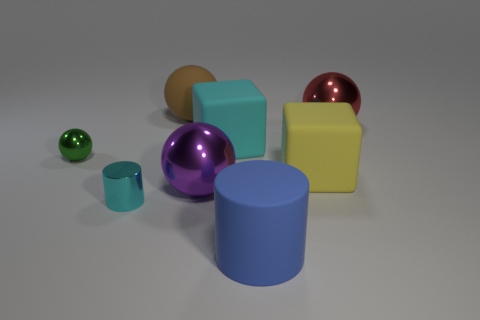There is a metallic thing on the right side of the big block left of the big matte thing in front of the cyan metal thing; what shape is it?
Make the answer very short. Sphere. What number of other things are the same color as the tiny cylinder?
Provide a short and direct response. 1. Is the number of large cyan objects in front of the large blue thing greater than the number of cyan shiny cylinders on the right side of the big red shiny sphere?
Provide a succinct answer. No. There is a yellow block; are there any big cylinders behind it?
Your answer should be very brief. No. There is a object that is left of the brown rubber ball and behind the small cylinder; what material is it made of?
Your answer should be very brief. Metal. There is a tiny thing that is the same shape as the big red object; what is its color?
Keep it short and to the point. Green. There is a small metallic thing that is in front of the purple ball; is there a tiny cylinder that is right of it?
Offer a very short reply. No. The matte cylinder has what size?
Keep it short and to the point. Large. There is a shiny object that is right of the large brown matte object and in front of the large red ball; what shape is it?
Make the answer very short. Sphere. How many brown objects are either big things or rubber cubes?
Your answer should be very brief. 1. 